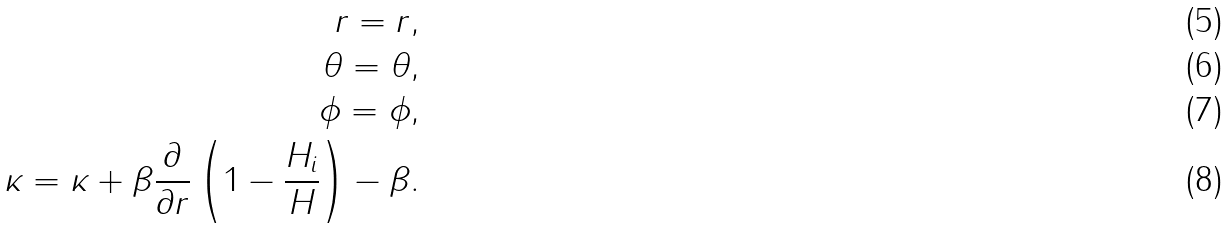<formula> <loc_0><loc_0><loc_500><loc_500>r = r , \\ \theta = \theta , \\ \phi = \phi , \\ \kappa = \kappa + \beta \frac { \partial } { \partial r } \left ( 1 - \frac { H _ { i } } { H } \right ) - \beta .</formula> 